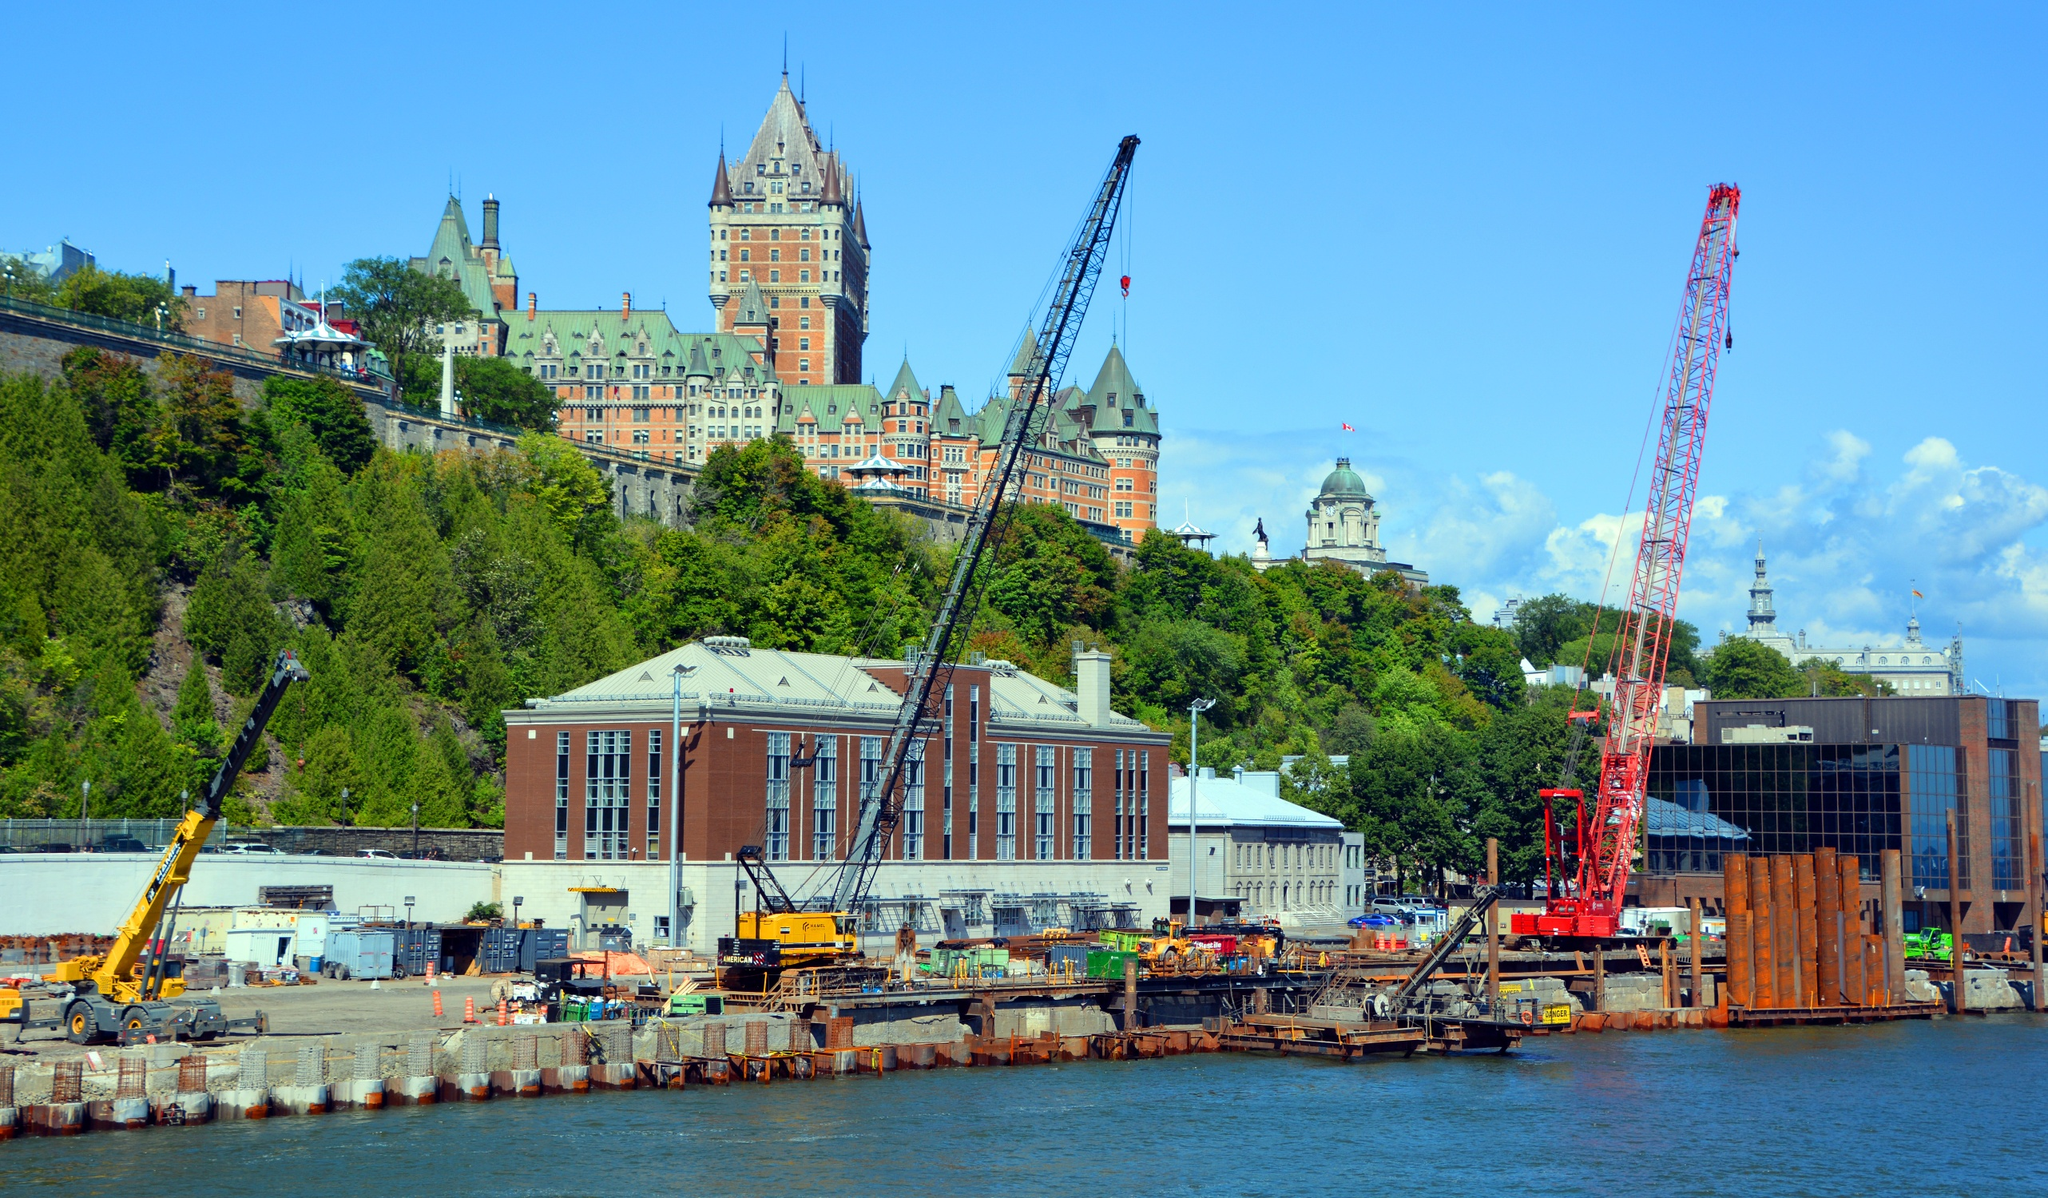Analyze the image in a comprehensive and detailed manner. The image showcases the iconic Château Frontenac, an emblematic historical hotel that majestically overlooks Quebec City, Canada. Its distinctive green copper roof and turrets elegantly pierce the azure sky, emphasizing its architectural grandeur. The hotel occupies an elevated position, strategically providing breathtaking panoramic vistas of the surrounding cityscape.

In the foreground, a bustling construction site signifies ongoing development, with cranes and various construction machinery active in their tasks. This contrast between the historical elegance of the Château Frontenac and the modern industrial activity highlights the dynamic evolution of the area.

Located across the shimmering waters of the St. Lawrence River, the vantage point of the image provides a harmonious blend of past and future. Additional elements such as the lush greenery along the hillside and the adjoining structures complement the multifaceted urban landscape. Consequently, the image vividly captures Quebec City's rich architectural heritage while simultaneously illustrating its continual growth and modernization. 